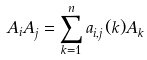Convert formula to latex. <formula><loc_0><loc_0><loc_500><loc_500>A _ { i } A _ { j } = \sum _ { k = 1 } ^ { n } a _ { i , j } ( k ) A _ { k } \\</formula> 